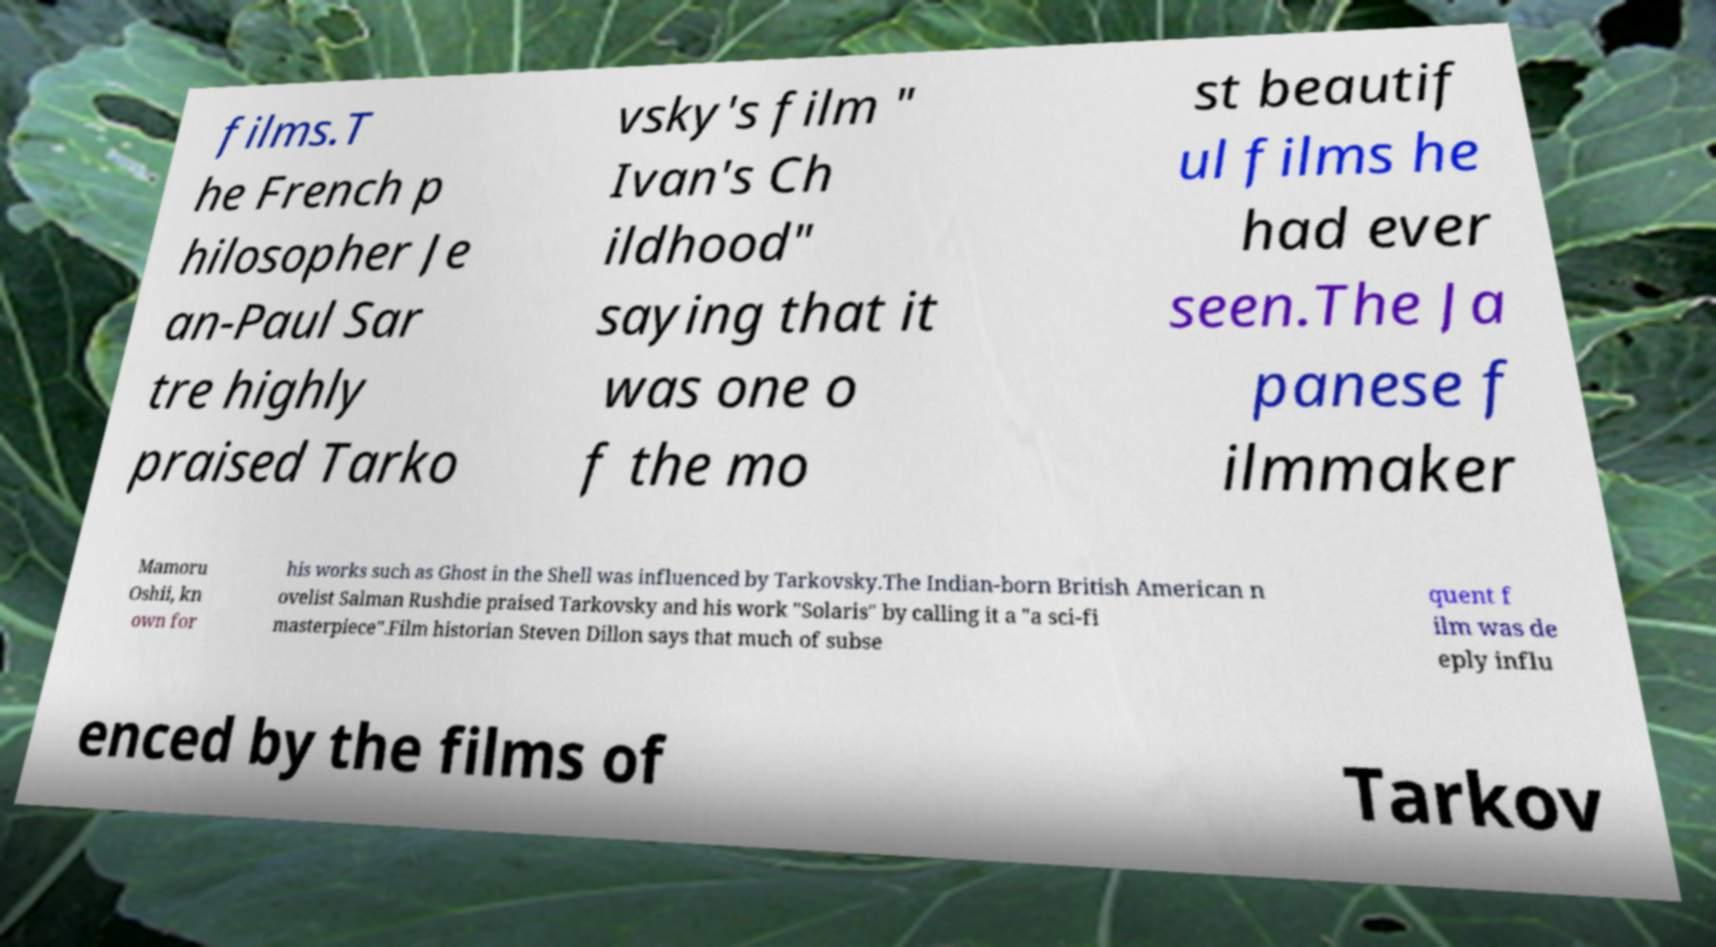Please identify and transcribe the text found in this image. films.T he French p hilosopher Je an-Paul Sar tre highly praised Tarko vsky's film " Ivan's Ch ildhood" saying that it was one o f the mo st beautif ul films he had ever seen.The Ja panese f ilmmaker Mamoru Oshii, kn own for his works such as Ghost in the Shell was influenced by Tarkovsky.The Indian-born British American n ovelist Salman Rushdie praised Tarkovsky and his work "Solaris" by calling it a "a sci-fi masterpiece".Film historian Steven Dillon says that much of subse quent f ilm was de eply influ enced by the films of Tarkov 